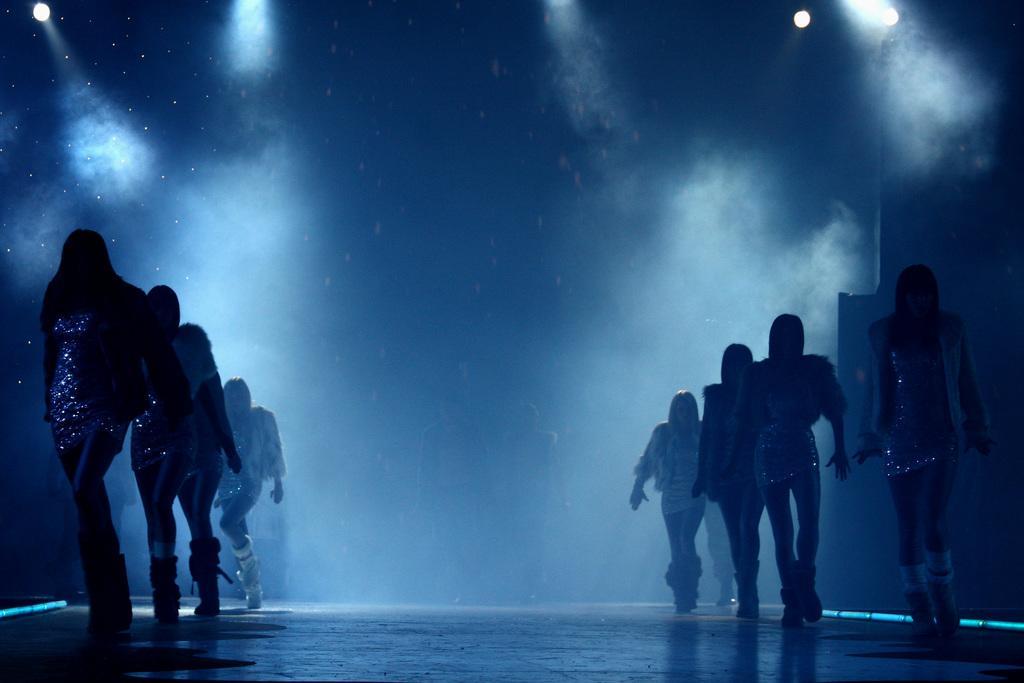Can you describe this image briefly? There are persons in two lines, doing performance on a stage. In the background, there are lights and there is smoke. 